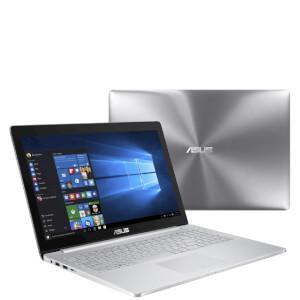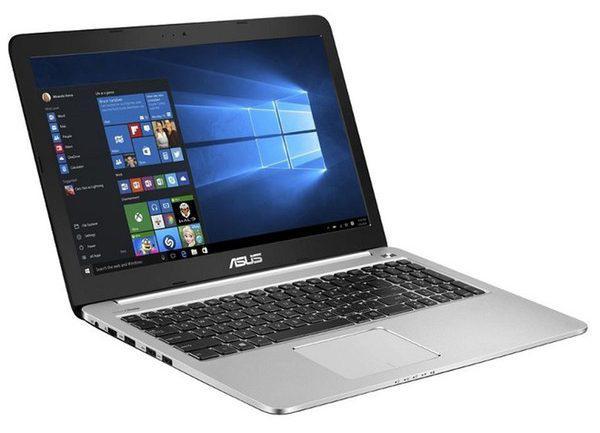The first image is the image on the left, the second image is the image on the right. Considering the images on both sides, is "The left image features an open, rightward facing laptop overlapping an upright closed silver laptop, and the right image contains only an open, rightward facing laptop." valid? Answer yes or no. Yes. The first image is the image on the left, the second image is the image on the right. Assess this claim about the two images: "One image contains only one laptop and the other image contains one open laptop and one closed laptop.". Correct or not? Answer yes or no. Yes. 